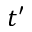Convert formula to latex. <formula><loc_0><loc_0><loc_500><loc_500>t ^ { \prime }</formula> 